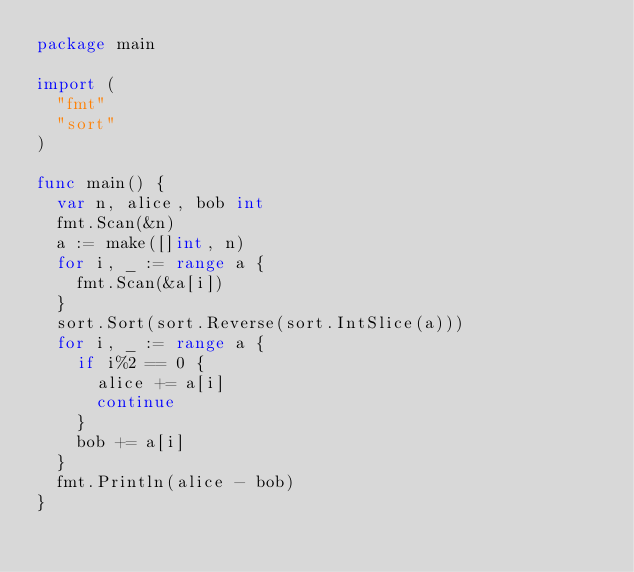Convert code to text. <code><loc_0><loc_0><loc_500><loc_500><_Go_>package main

import (
	"fmt"
	"sort"
)

func main() {
	var n, alice, bob int
	fmt.Scan(&n)
	a := make([]int, n)
	for i, _ := range a {
		fmt.Scan(&a[i])
	}
	sort.Sort(sort.Reverse(sort.IntSlice(a)))
	for i, _ := range a {
		if i%2 == 0 {
			alice += a[i]
			continue
		}
		bob += a[i]
	}
	fmt.Println(alice - bob)
}
</code> 